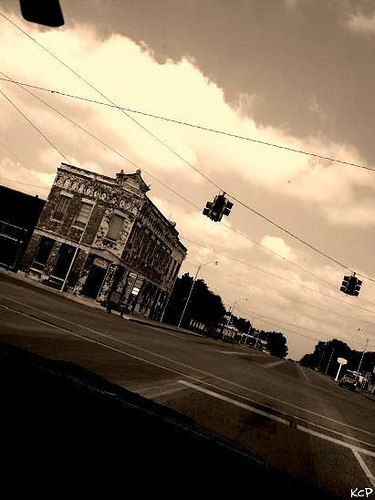Identify the text contained in this image. KCP 